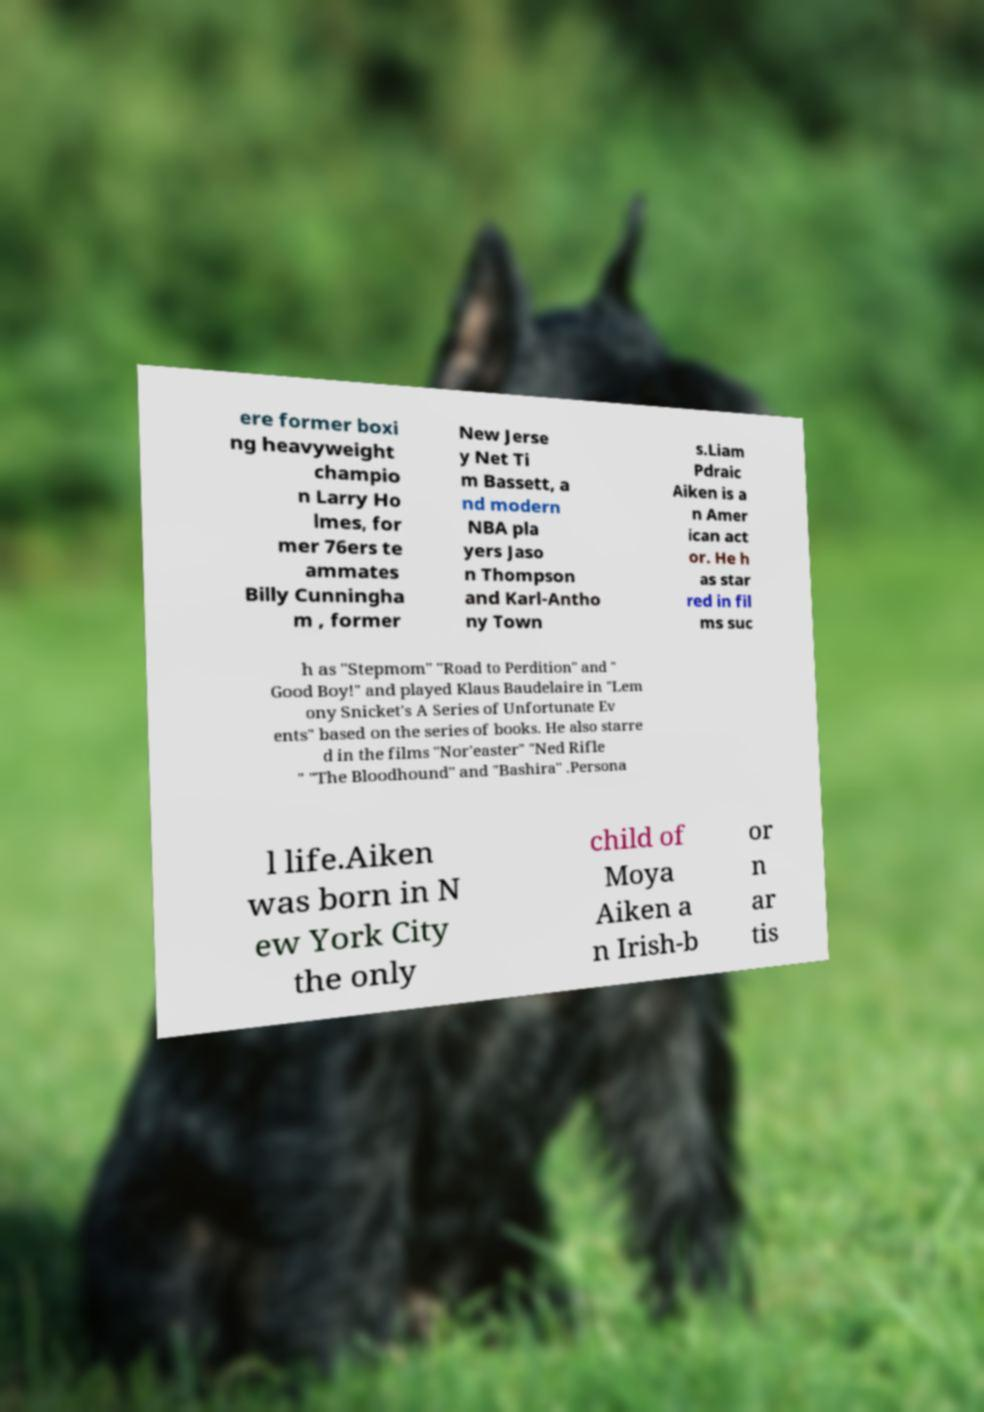There's text embedded in this image that I need extracted. Can you transcribe it verbatim? ere former boxi ng heavyweight champio n Larry Ho lmes, for mer 76ers te ammates Billy Cunningha m , former New Jerse y Net Ti m Bassett, a nd modern NBA pla yers Jaso n Thompson and Karl-Antho ny Town s.Liam Pdraic Aiken is a n Amer ican act or. He h as star red in fil ms suc h as "Stepmom" "Road to Perdition" and " Good Boy!" and played Klaus Baudelaire in "Lem ony Snicket's A Series of Unfortunate Ev ents" based on the series of books. He also starre d in the films "Nor'easter" "Ned Rifle " "The Bloodhound" and "Bashira" .Persona l life.Aiken was born in N ew York City the only child of Moya Aiken a n Irish-b or n ar tis 